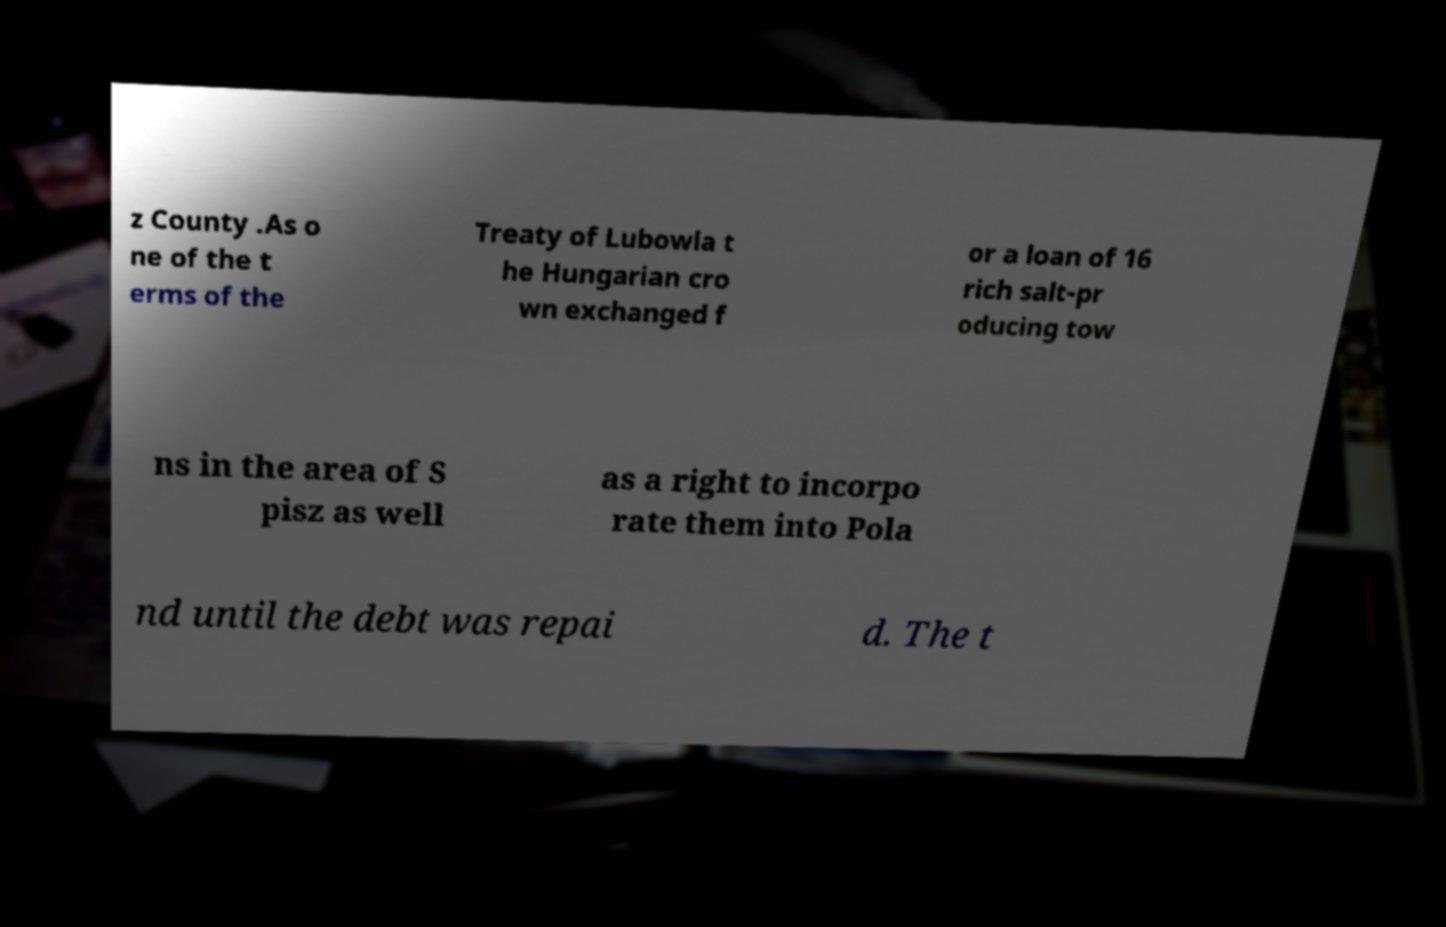For documentation purposes, I need the text within this image transcribed. Could you provide that? z County .As o ne of the t erms of the Treaty of Lubowla t he Hungarian cro wn exchanged f or a loan of 16 rich salt-pr oducing tow ns in the area of S pisz as well as a right to incorpo rate them into Pola nd until the debt was repai d. The t 